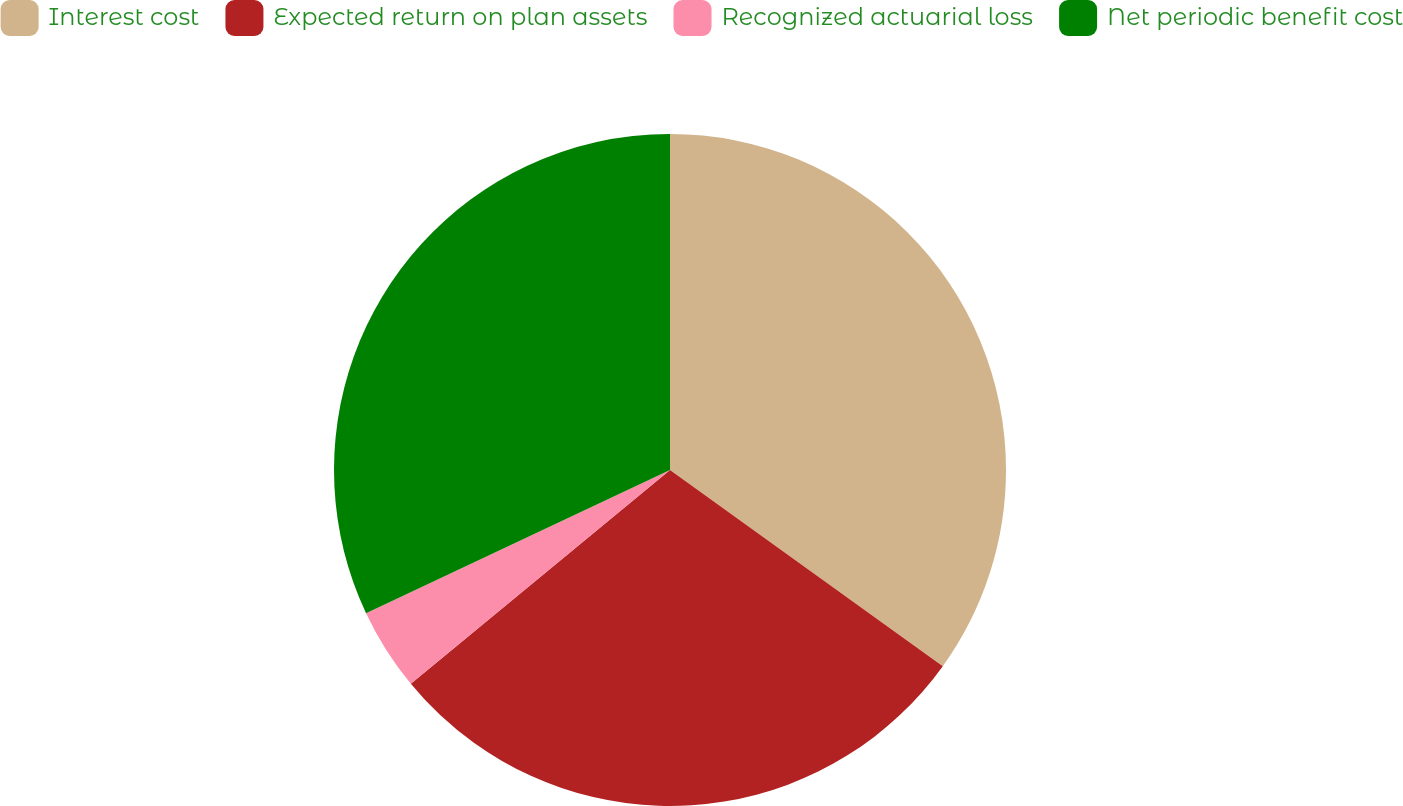Convert chart. <chart><loc_0><loc_0><loc_500><loc_500><pie_chart><fcel>Interest cost<fcel>Expected return on plan assets<fcel>Recognized actuarial loss<fcel>Net periodic benefit cost<nl><fcel>34.92%<fcel>29.1%<fcel>3.97%<fcel>32.01%<nl></chart> 